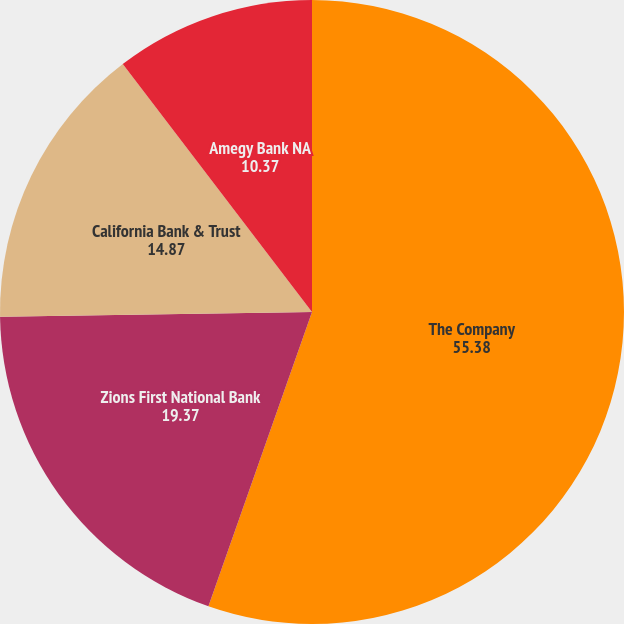Convert chart to OTSL. <chart><loc_0><loc_0><loc_500><loc_500><pie_chart><fcel>The Company<fcel>Zions First National Bank<fcel>California Bank & Trust<fcel>Amegy Bank NA<nl><fcel>55.38%<fcel>19.37%<fcel>14.87%<fcel>10.37%<nl></chart> 